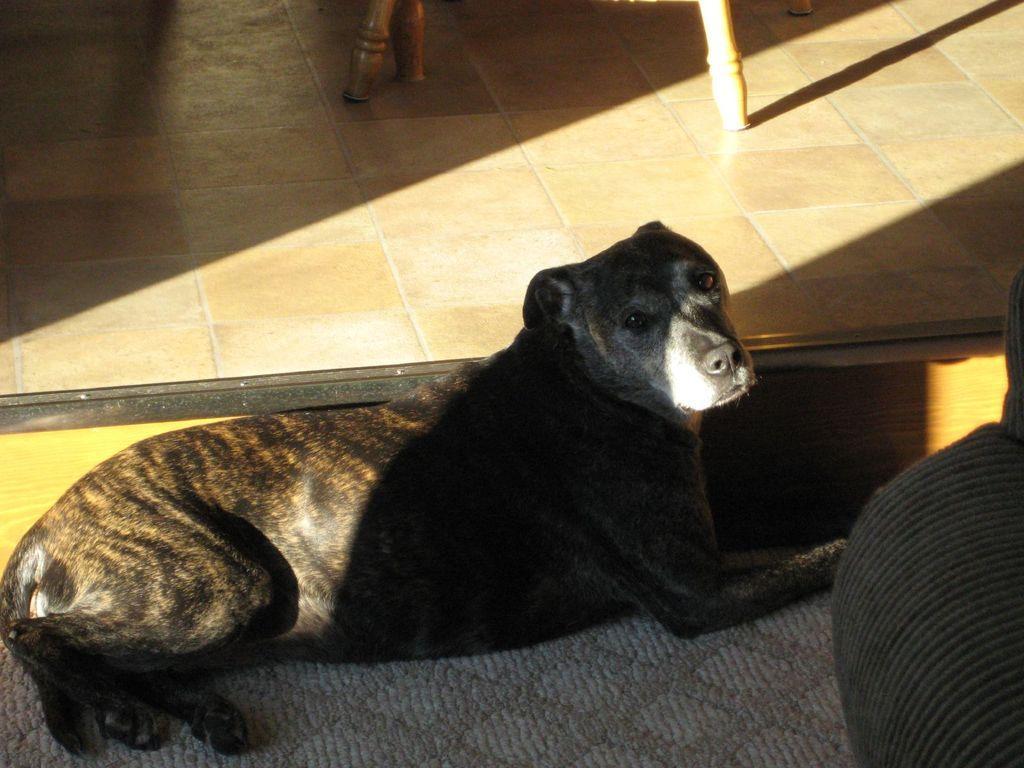Describe this image in one or two sentences. At the bottom of this image, there is a black color dog on a gray color carpet. Behind this dog, there is a rod. In the background, there are wooden sticks and shadows on the floor. 